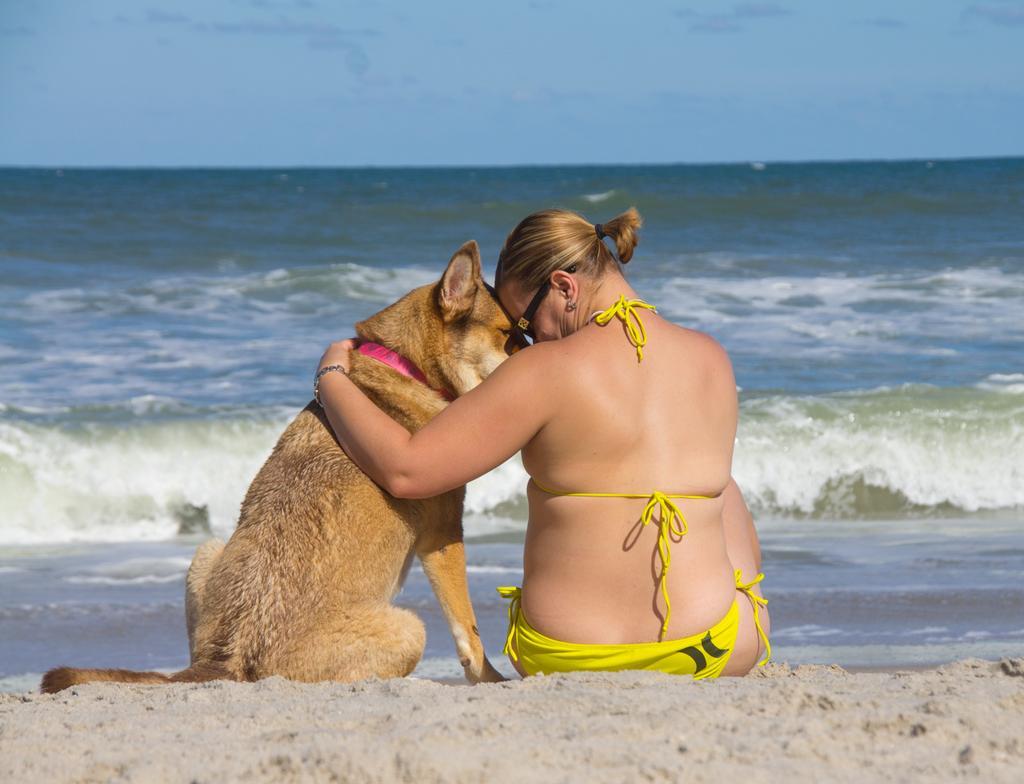In one or two sentences, can you explain what this image depicts? In this image I can see a person and the dog sitting on the sand. In front of them there is a water and the sky. 